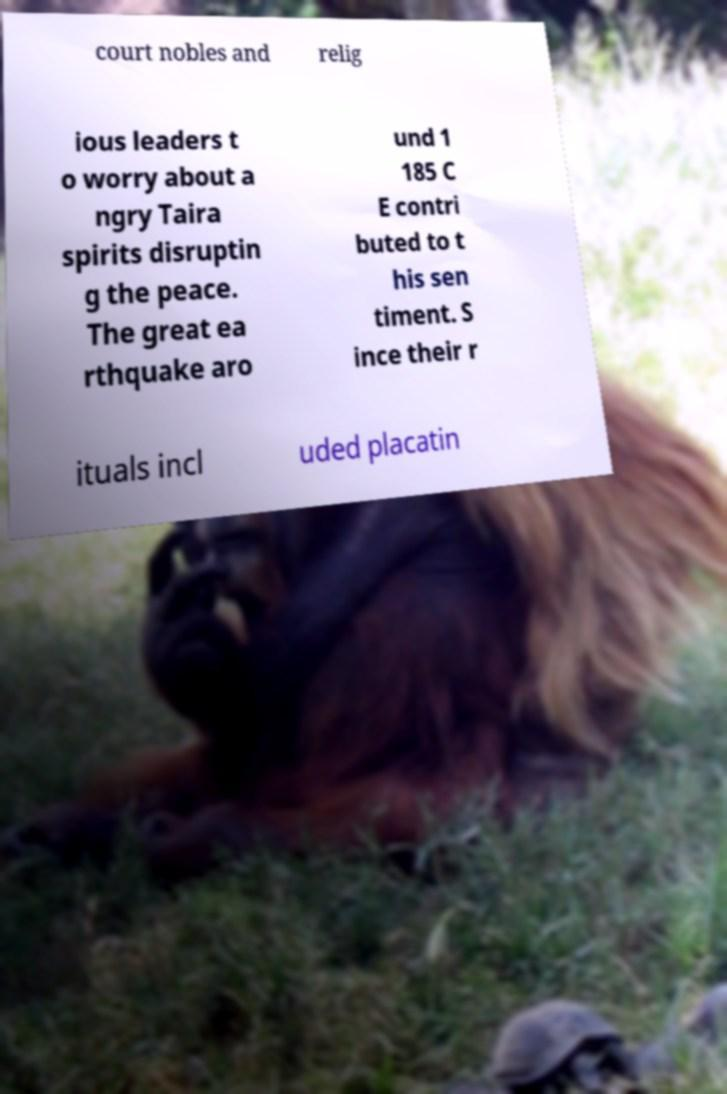Can you accurately transcribe the text from the provided image for me? court nobles and relig ious leaders t o worry about a ngry Taira spirits disruptin g the peace. The great ea rthquake aro und 1 185 C E contri buted to t his sen timent. S ince their r ituals incl uded placatin 